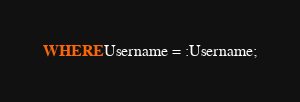Convert code to text. <code><loc_0><loc_0><loc_500><loc_500><_SQL_>WHERE Username = :Username;
</code> 